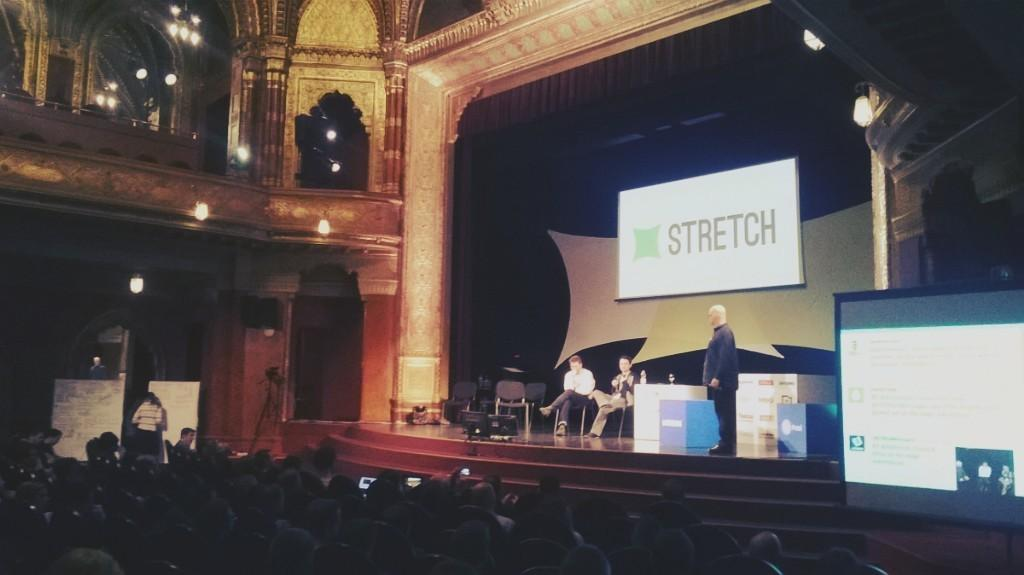<image>
Create a compact narrative representing the image presented. a sign that says stretch on the front of it 